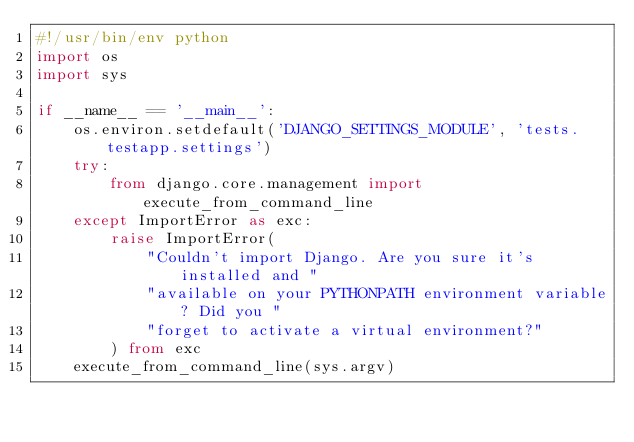Convert code to text. <code><loc_0><loc_0><loc_500><loc_500><_Python_>#!/usr/bin/env python
import os
import sys

if __name__ == '__main__':
    os.environ.setdefault('DJANGO_SETTINGS_MODULE', 'tests.testapp.settings')
    try:
        from django.core.management import execute_from_command_line
    except ImportError as exc:
        raise ImportError(
            "Couldn't import Django. Are you sure it's installed and "
            "available on your PYTHONPATH environment variable? Did you "
            "forget to activate a virtual environment?"
        ) from exc
    execute_from_command_line(sys.argv)
</code> 